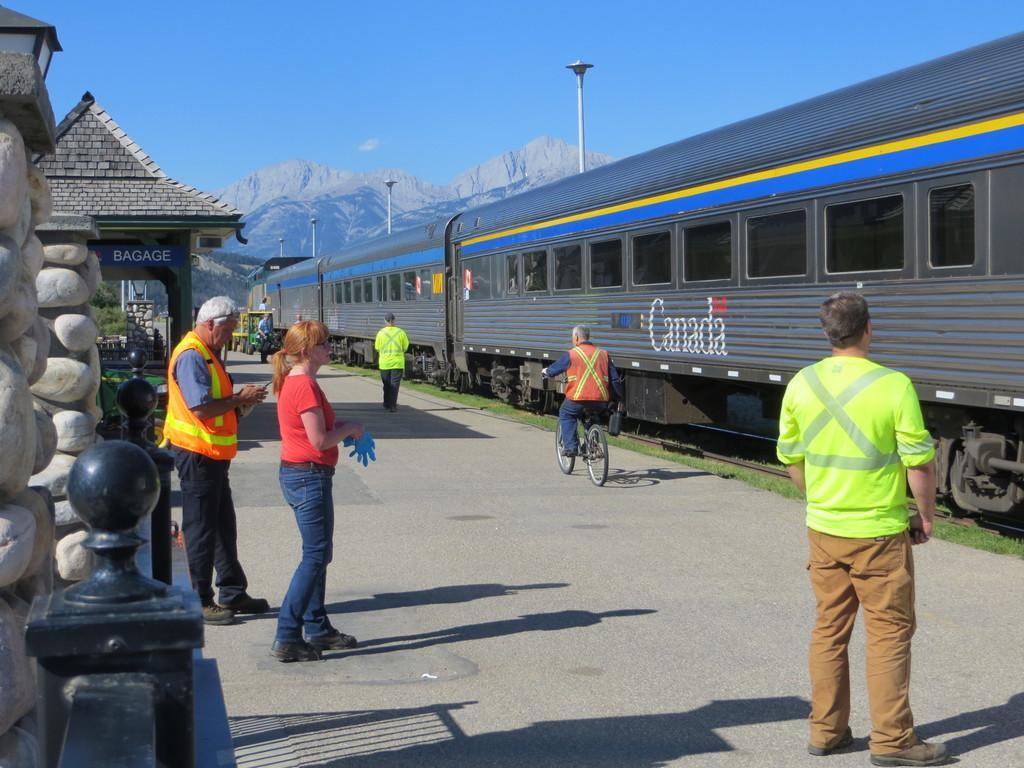Can you describe this image briefly? In this picture I can see people standing on the surface. I can see a person riding bicycle on the right side. I can see the railway bogies on the right side. I can see mountains in the background. I can see clouds in the sky. 